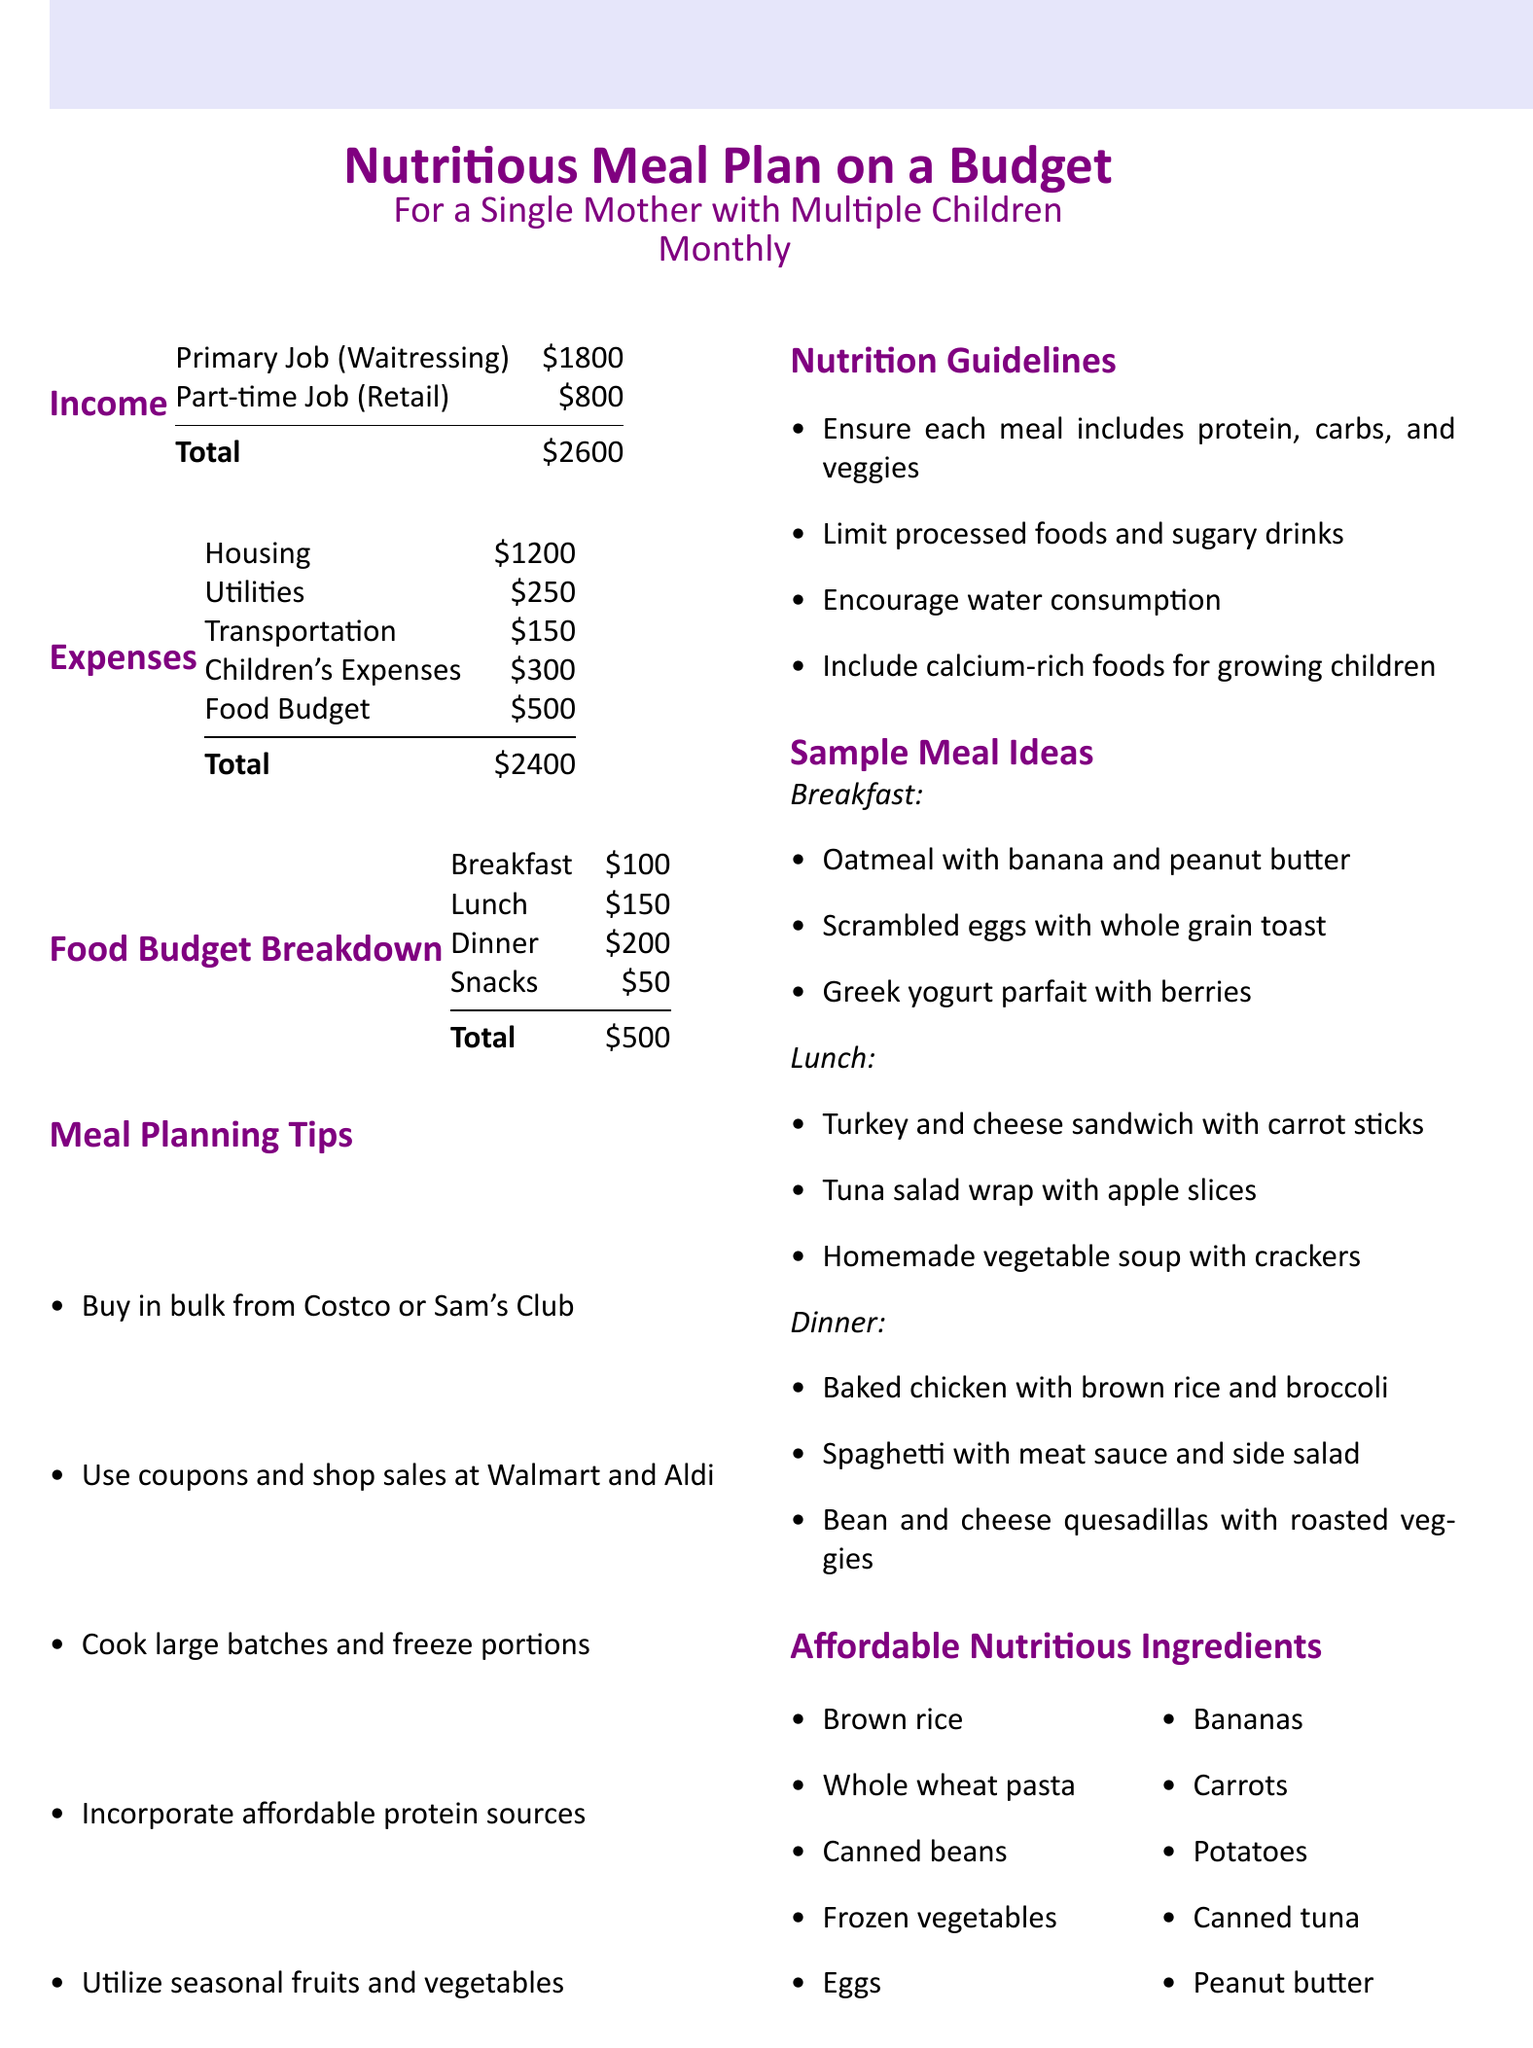What is the total income? The total income is the sum of the primary job and part-time job incomes, which is $1800 + $800 = $2600.
Answer: $2600 What is the food budget? The food budget is explicitly stated in the expenses section of the document.
Answer: $500 How much is allocated for breakfast in the food budget? The document specifies that the breakfast allocation is part of the food budget breakdown.
Answer: $100 What types of stores are recommended for buying groceries? The Meal Planning Tips section suggests various stores for bulk buying and grocery shopping.
Answer: Costco, Sam's Club, Walmart, Aldi What should each meal include according to the nutrition guidelines? The nutrition guidelines recommend that every meal includes certain key components for balanced nutrition.
Answer: Protein, carbs, and veggies How much is spent on children's expenses? The expenses table shows how much is allocated for children's costs each month.
Answer: $300 What is one suggested breakfast item? The Sample Meal Ideas for breakfast lists various nutritious options, allowing for a simple retrieval of one item.
Answer: Oatmeal with banana and peanut butter What is a recommended action for minimizing food costs? The Meal Planning Tips provide several strategies for budgeting and food savings.
Answer: Buy in bulk 